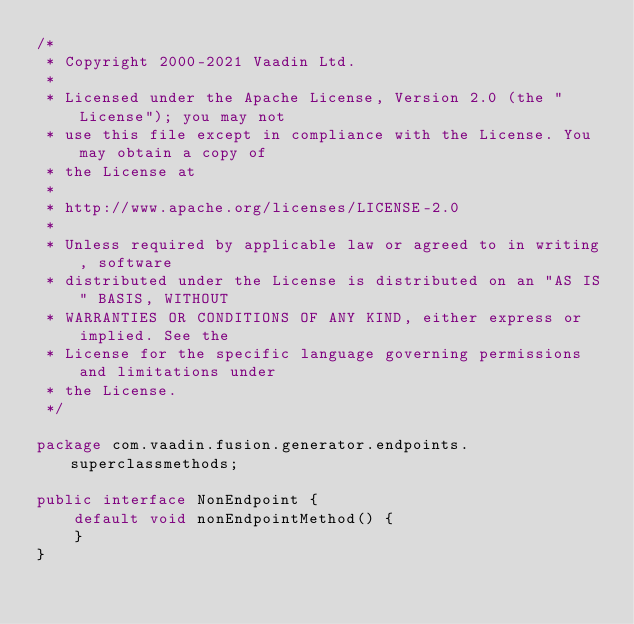<code> <loc_0><loc_0><loc_500><loc_500><_Java_>/*
 * Copyright 2000-2021 Vaadin Ltd.
 *
 * Licensed under the Apache License, Version 2.0 (the "License"); you may not
 * use this file except in compliance with the License. You may obtain a copy of
 * the License at
 *
 * http://www.apache.org/licenses/LICENSE-2.0
 *
 * Unless required by applicable law or agreed to in writing, software
 * distributed under the License is distributed on an "AS IS" BASIS, WITHOUT
 * WARRANTIES OR CONDITIONS OF ANY KIND, either express or implied. See the
 * License for the specific language governing permissions and limitations under
 * the License.
 */

package com.vaadin.fusion.generator.endpoints.superclassmethods;

public interface NonEndpoint {
    default void nonEndpointMethod() {
    }
}
</code> 